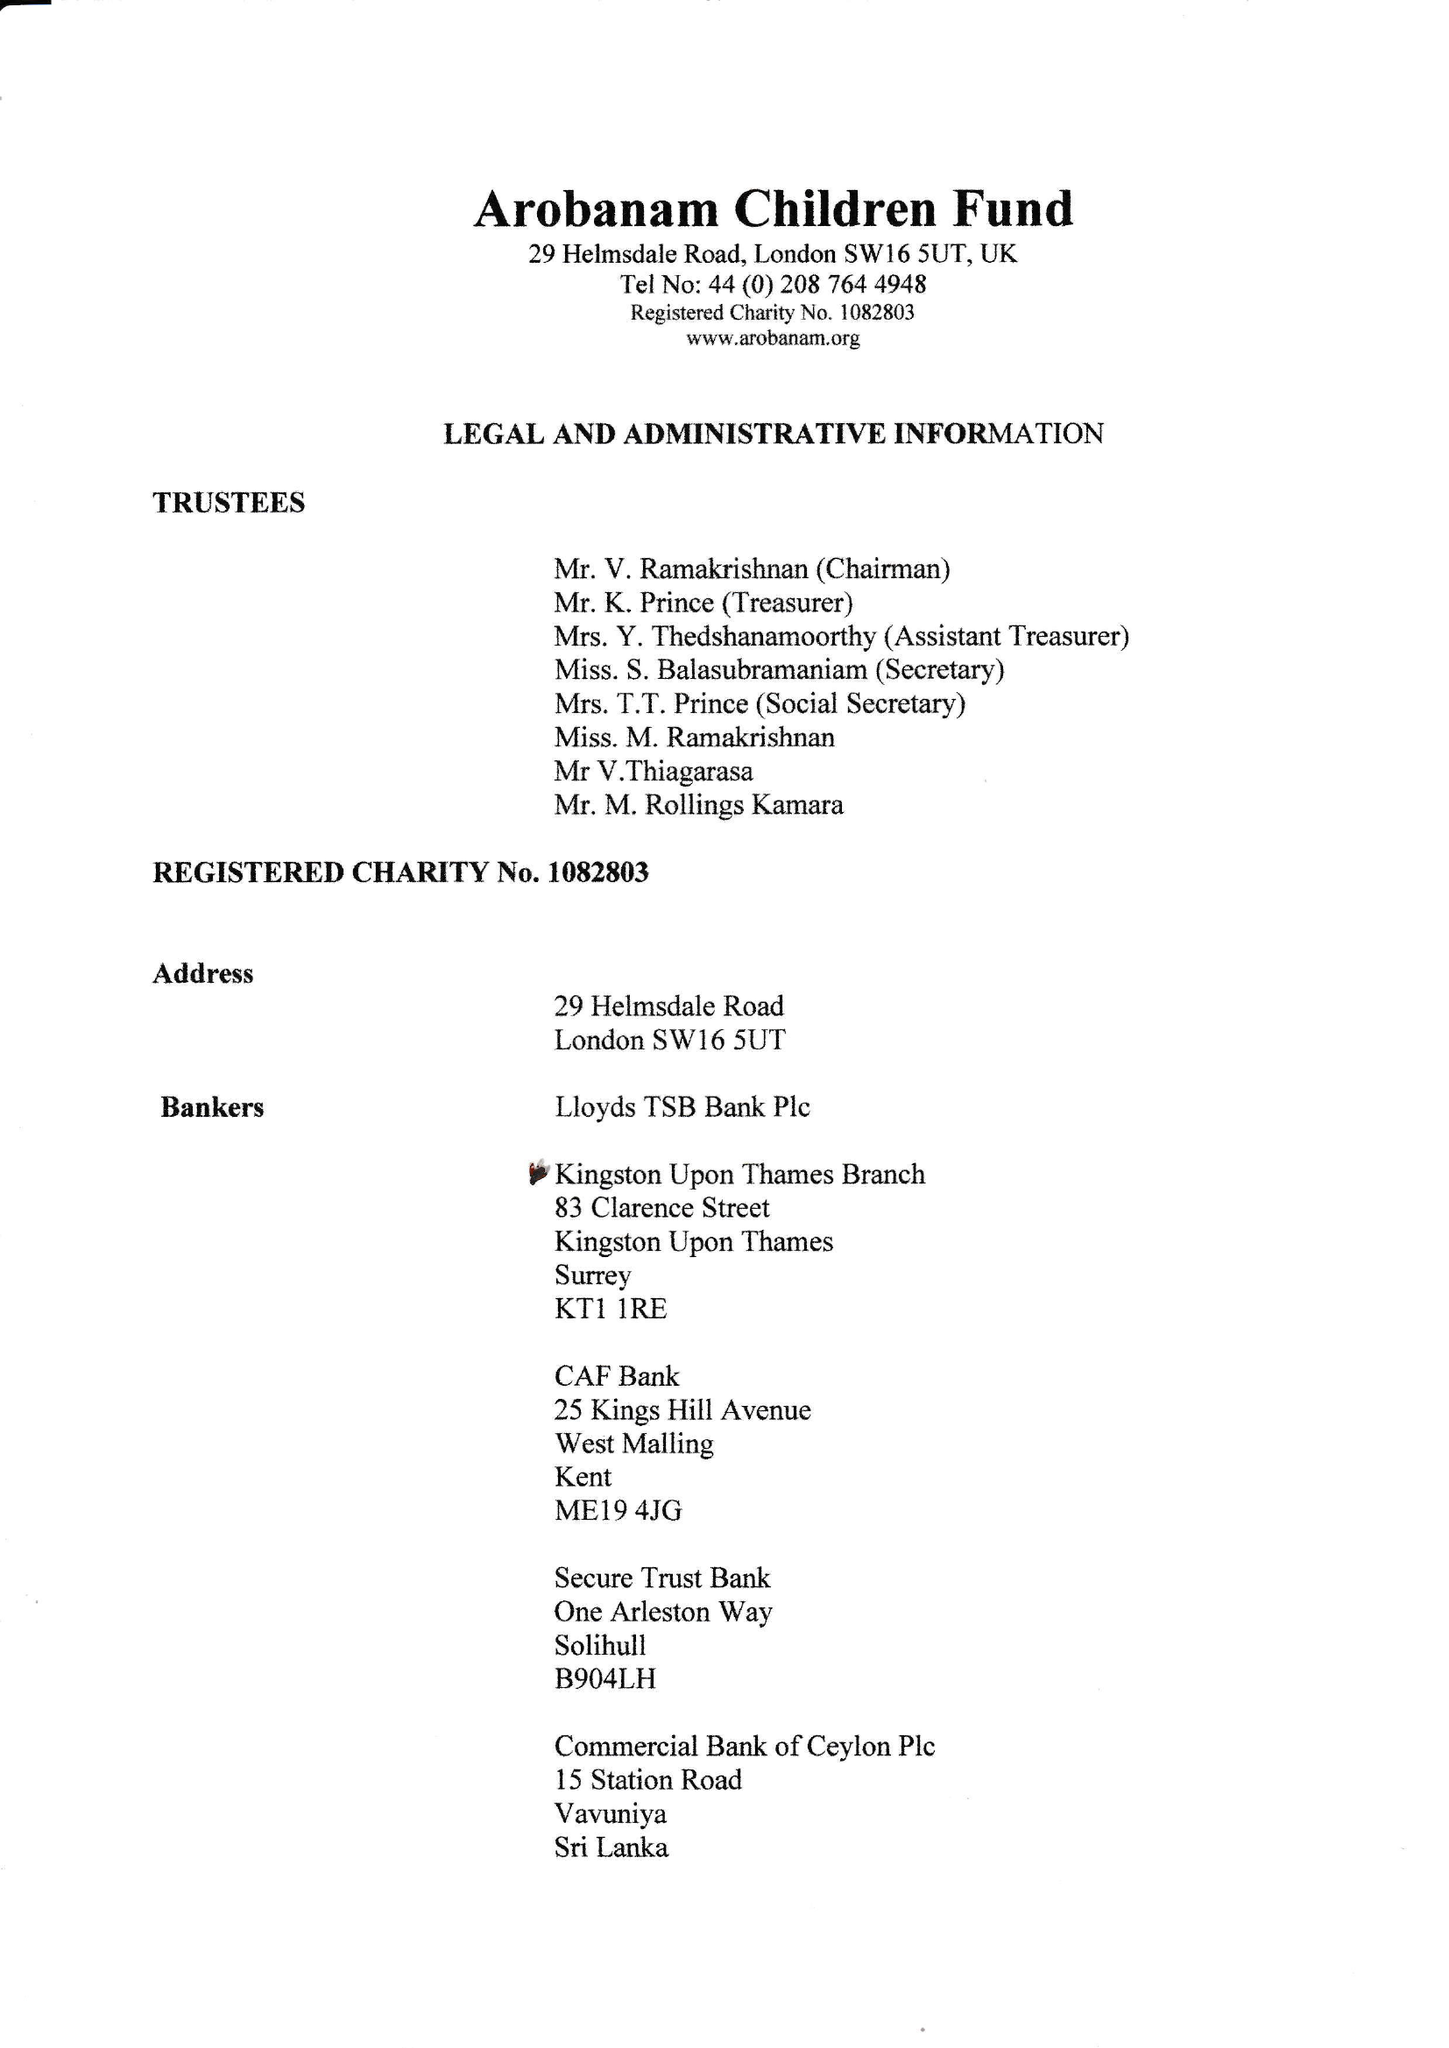What is the value for the charity_name?
Answer the question using a single word or phrase. Arobanam Children Fund 